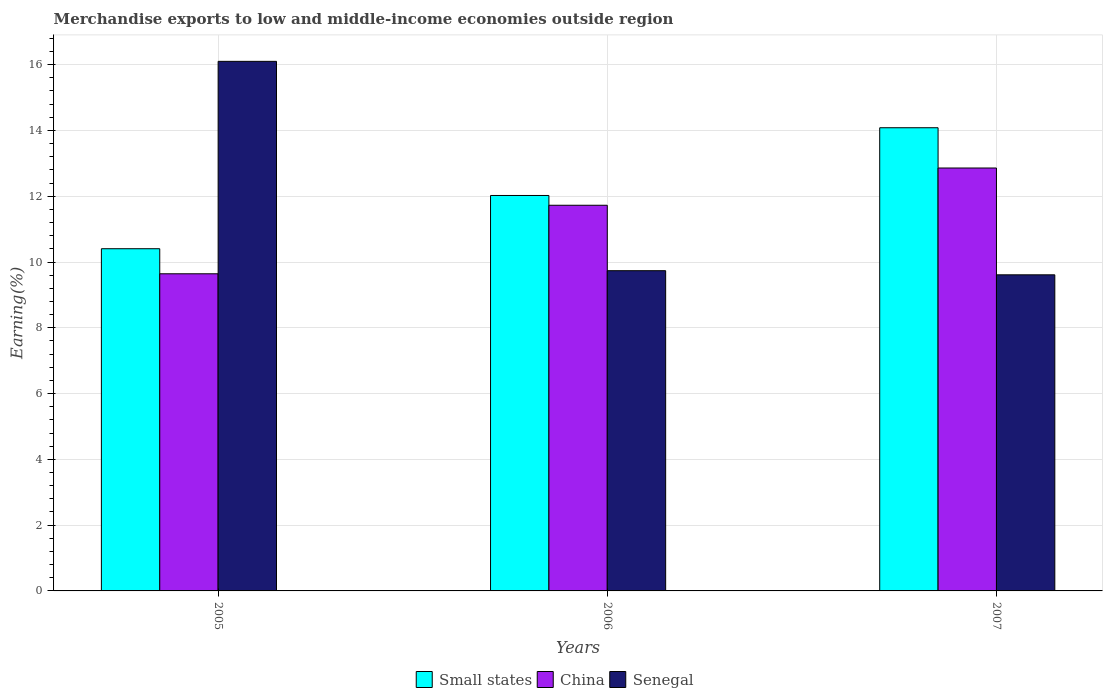How many groups of bars are there?
Make the answer very short. 3. Are the number of bars on each tick of the X-axis equal?
Ensure brevity in your answer.  Yes. How many bars are there on the 1st tick from the right?
Your answer should be very brief. 3. In how many cases, is the number of bars for a given year not equal to the number of legend labels?
Offer a terse response. 0. What is the percentage of amount earned from merchandise exports in Senegal in 2006?
Offer a terse response. 9.74. Across all years, what is the maximum percentage of amount earned from merchandise exports in China?
Keep it short and to the point. 12.86. Across all years, what is the minimum percentage of amount earned from merchandise exports in Senegal?
Offer a terse response. 9.61. What is the total percentage of amount earned from merchandise exports in China in the graph?
Provide a short and direct response. 34.22. What is the difference between the percentage of amount earned from merchandise exports in China in 2005 and that in 2006?
Ensure brevity in your answer.  -2.08. What is the difference between the percentage of amount earned from merchandise exports in China in 2005 and the percentage of amount earned from merchandise exports in Small states in 2006?
Provide a short and direct response. -2.38. What is the average percentage of amount earned from merchandise exports in Small states per year?
Your answer should be very brief. 12.17. In the year 2006, what is the difference between the percentage of amount earned from merchandise exports in Senegal and percentage of amount earned from merchandise exports in China?
Provide a short and direct response. -1.99. What is the ratio of the percentage of amount earned from merchandise exports in Senegal in 2005 to that in 2006?
Make the answer very short. 1.65. What is the difference between the highest and the second highest percentage of amount earned from merchandise exports in China?
Make the answer very short. 1.13. What is the difference between the highest and the lowest percentage of amount earned from merchandise exports in Senegal?
Keep it short and to the point. 6.49. In how many years, is the percentage of amount earned from merchandise exports in Senegal greater than the average percentage of amount earned from merchandise exports in Senegal taken over all years?
Keep it short and to the point. 1. Is the sum of the percentage of amount earned from merchandise exports in Senegal in 2005 and 2007 greater than the maximum percentage of amount earned from merchandise exports in Small states across all years?
Your answer should be very brief. Yes. Is it the case that in every year, the sum of the percentage of amount earned from merchandise exports in China and percentage of amount earned from merchandise exports in Small states is greater than the percentage of amount earned from merchandise exports in Senegal?
Offer a very short reply. Yes. How many bars are there?
Make the answer very short. 9. How many years are there in the graph?
Your response must be concise. 3. Are the values on the major ticks of Y-axis written in scientific E-notation?
Provide a succinct answer. No. What is the title of the graph?
Offer a terse response. Merchandise exports to low and middle-income economies outside region. Does "Middle East & North Africa (all income levels)" appear as one of the legend labels in the graph?
Give a very brief answer. No. What is the label or title of the Y-axis?
Make the answer very short. Earning(%). What is the Earning(%) in Small states in 2005?
Keep it short and to the point. 10.4. What is the Earning(%) in China in 2005?
Offer a very short reply. 9.64. What is the Earning(%) of Senegal in 2005?
Keep it short and to the point. 16.1. What is the Earning(%) in Small states in 2006?
Offer a very short reply. 12.02. What is the Earning(%) of China in 2006?
Ensure brevity in your answer.  11.73. What is the Earning(%) of Senegal in 2006?
Give a very brief answer. 9.74. What is the Earning(%) in Small states in 2007?
Offer a very short reply. 14.08. What is the Earning(%) in China in 2007?
Ensure brevity in your answer.  12.86. What is the Earning(%) of Senegal in 2007?
Offer a terse response. 9.61. Across all years, what is the maximum Earning(%) in Small states?
Keep it short and to the point. 14.08. Across all years, what is the maximum Earning(%) in China?
Keep it short and to the point. 12.86. Across all years, what is the maximum Earning(%) in Senegal?
Ensure brevity in your answer.  16.1. Across all years, what is the minimum Earning(%) in Small states?
Your answer should be compact. 10.4. Across all years, what is the minimum Earning(%) of China?
Offer a terse response. 9.64. Across all years, what is the minimum Earning(%) of Senegal?
Offer a terse response. 9.61. What is the total Earning(%) in Small states in the graph?
Keep it short and to the point. 36.51. What is the total Earning(%) of China in the graph?
Ensure brevity in your answer.  34.22. What is the total Earning(%) in Senegal in the graph?
Make the answer very short. 35.45. What is the difference between the Earning(%) in Small states in 2005 and that in 2006?
Offer a very short reply. -1.62. What is the difference between the Earning(%) in China in 2005 and that in 2006?
Provide a succinct answer. -2.08. What is the difference between the Earning(%) in Senegal in 2005 and that in 2006?
Offer a terse response. 6.36. What is the difference between the Earning(%) in Small states in 2005 and that in 2007?
Your response must be concise. -3.68. What is the difference between the Earning(%) in China in 2005 and that in 2007?
Make the answer very short. -3.22. What is the difference between the Earning(%) of Senegal in 2005 and that in 2007?
Offer a very short reply. 6.49. What is the difference between the Earning(%) in Small states in 2006 and that in 2007?
Ensure brevity in your answer.  -2.06. What is the difference between the Earning(%) in China in 2006 and that in 2007?
Offer a very short reply. -1.13. What is the difference between the Earning(%) in Senegal in 2006 and that in 2007?
Keep it short and to the point. 0.13. What is the difference between the Earning(%) in Small states in 2005 and the Earning(%) in China in 2006?
Your answer should be very brief. -1.32. What is the difference between the Earning(%) in Small states in 2005 and the Earning(%) in Senegal in 2006?
Make the answer very short. 0.67. What is the difference between the Earning(%) of China in 2005 and the Earning(%) of Senegal in 2006?
Provide a short and direct response. -0.09. What is the difference between the Earning(%) of Small states in 2005 and the Earning(%) of China in 2007?
Ensure brevity in your answer.  -2.45. What is the difference between the Earning(%) in Small states in 2005 and the Earning(%) in Senegal in 2007?
Your response must be concise. 0.79. What is the difference between the Earning(%) in China in 2005 and the Earning(%) in Senegal in 2007?
Provide a succinct answer. 0.03. What is the difference between the Earning(%) in Small states in 2006 and the Earning(%) in China in 2007?
Give a very brief answer. -0.84. What is the difference between the Earning(%) in Small states in 2006 and the Earning(%) in Senegal in 2007?
Offer a very short reply. 2.41. What is the difference between the Earning(%) of China in 2006 and the Earning(%) of Senegal in 2007?
Offer a very short reply. 2.11. What is the average Earning(%) in Small states per year?
Your response must be concise. 12.17. What is the average Earning(%) of China per year?
Your answer should be very brief. 11.41. What is the average Earning(%) in Senegal per year?
Make the answer very short. 11.82. In the year 2005, what is the difference between the Earning(%) of Small states and Earning(%) of China?
Keep it short and to the point. 0.76. In the year 2005, what is the difference between the Earning(%) of Small states and Earning(%) of Senegal?
Ensure brevity in your answer.  -5.7. In the year 2005, what is the difference between the Earning(%) of China and Earning(%) of Senegal?
Your answer should be compact. -6.46. In the year 2006, what is the difference between the Earning(%) of Small states and Earning(%) of China?
Offer a terse response. 0.3. In the year 2006, what is the difference between the Earning(%) of Small states and Earning(%) of Senegal?
Offer a very short reply. 2.29. In the year 2006, what is the difference between the Earning(%) of China and Earning(%) of Senegal?
Provide a short and direct response. 1.99. In the year 2007, what is the difference between the Earning(%) of Small states and Earning(%) of China?
Your response must be concise. 1.22. In the year 2007, what is the difference between the Earning(%) of Small states and Earning(%) of Senegal?
Give a very brief answer. 4.47. In the year 2007, what is the difference between the Earning(%) of China and Earning(%) of Senegal?
Keep it short and to the point. 3.25. What is the ratio of the Earning(%) in Small states in 2005 to that in 2006?
Offer a terse response. 0.87. What is the ratio of the Earning(%) in China in 2005 to that in 2006?
Keep it short and to the point. 0.82. What is the ratio of the Earning(%) of Senegal in 2005 to that in 2006?
Offer a terse response. 1.65. What is the ratio of the Earning(%) in Small states in 2005 to that in 2007?
Provide a short and direct response. 0.74. What is the ratio of the Earning(%) in China in 2005 to that in 2007?
Ensure brevity in your answer.  0.75. What is the ratio of the Earning(%) of Senegal in 2005 to that in 2007?
Ensure brevity in your answer.  1.68. What is the ratio of the Earning(%) in Small states in 2006 to that in 2007?
Keep it short and to the point. 0.85. What is the ratio of the Earning(%) in China in 2006 to that in 2007?
Ensure brevity in your answer.  0.91. What is the ratio of the Earning(%) of Senegal in 2006 to that in 2007?
Offer a terse response. 1.01. What is the difference between the highest and the second highest Earning(%) in Small states?
Offer a terse response. 2.06. What is the difference between the highest and the second highest Earning(%) in China?
Give a very brief answer. 1.13. What is the difference between the highest and the second highest Earning(%) of Senegal?
Give a very brief answer. 6.36. What is the difference between the highest and the lowest Earning(%) of Small states?
Your answer should be very brief. 3.68. What is the difference between the highest and the lowest Earning(%) in China?
Offer a terse response. 3.22. What is the difference between the highest and the lowest Earning(%) of Senegal?
Provide a succinct answer. 6.49. 